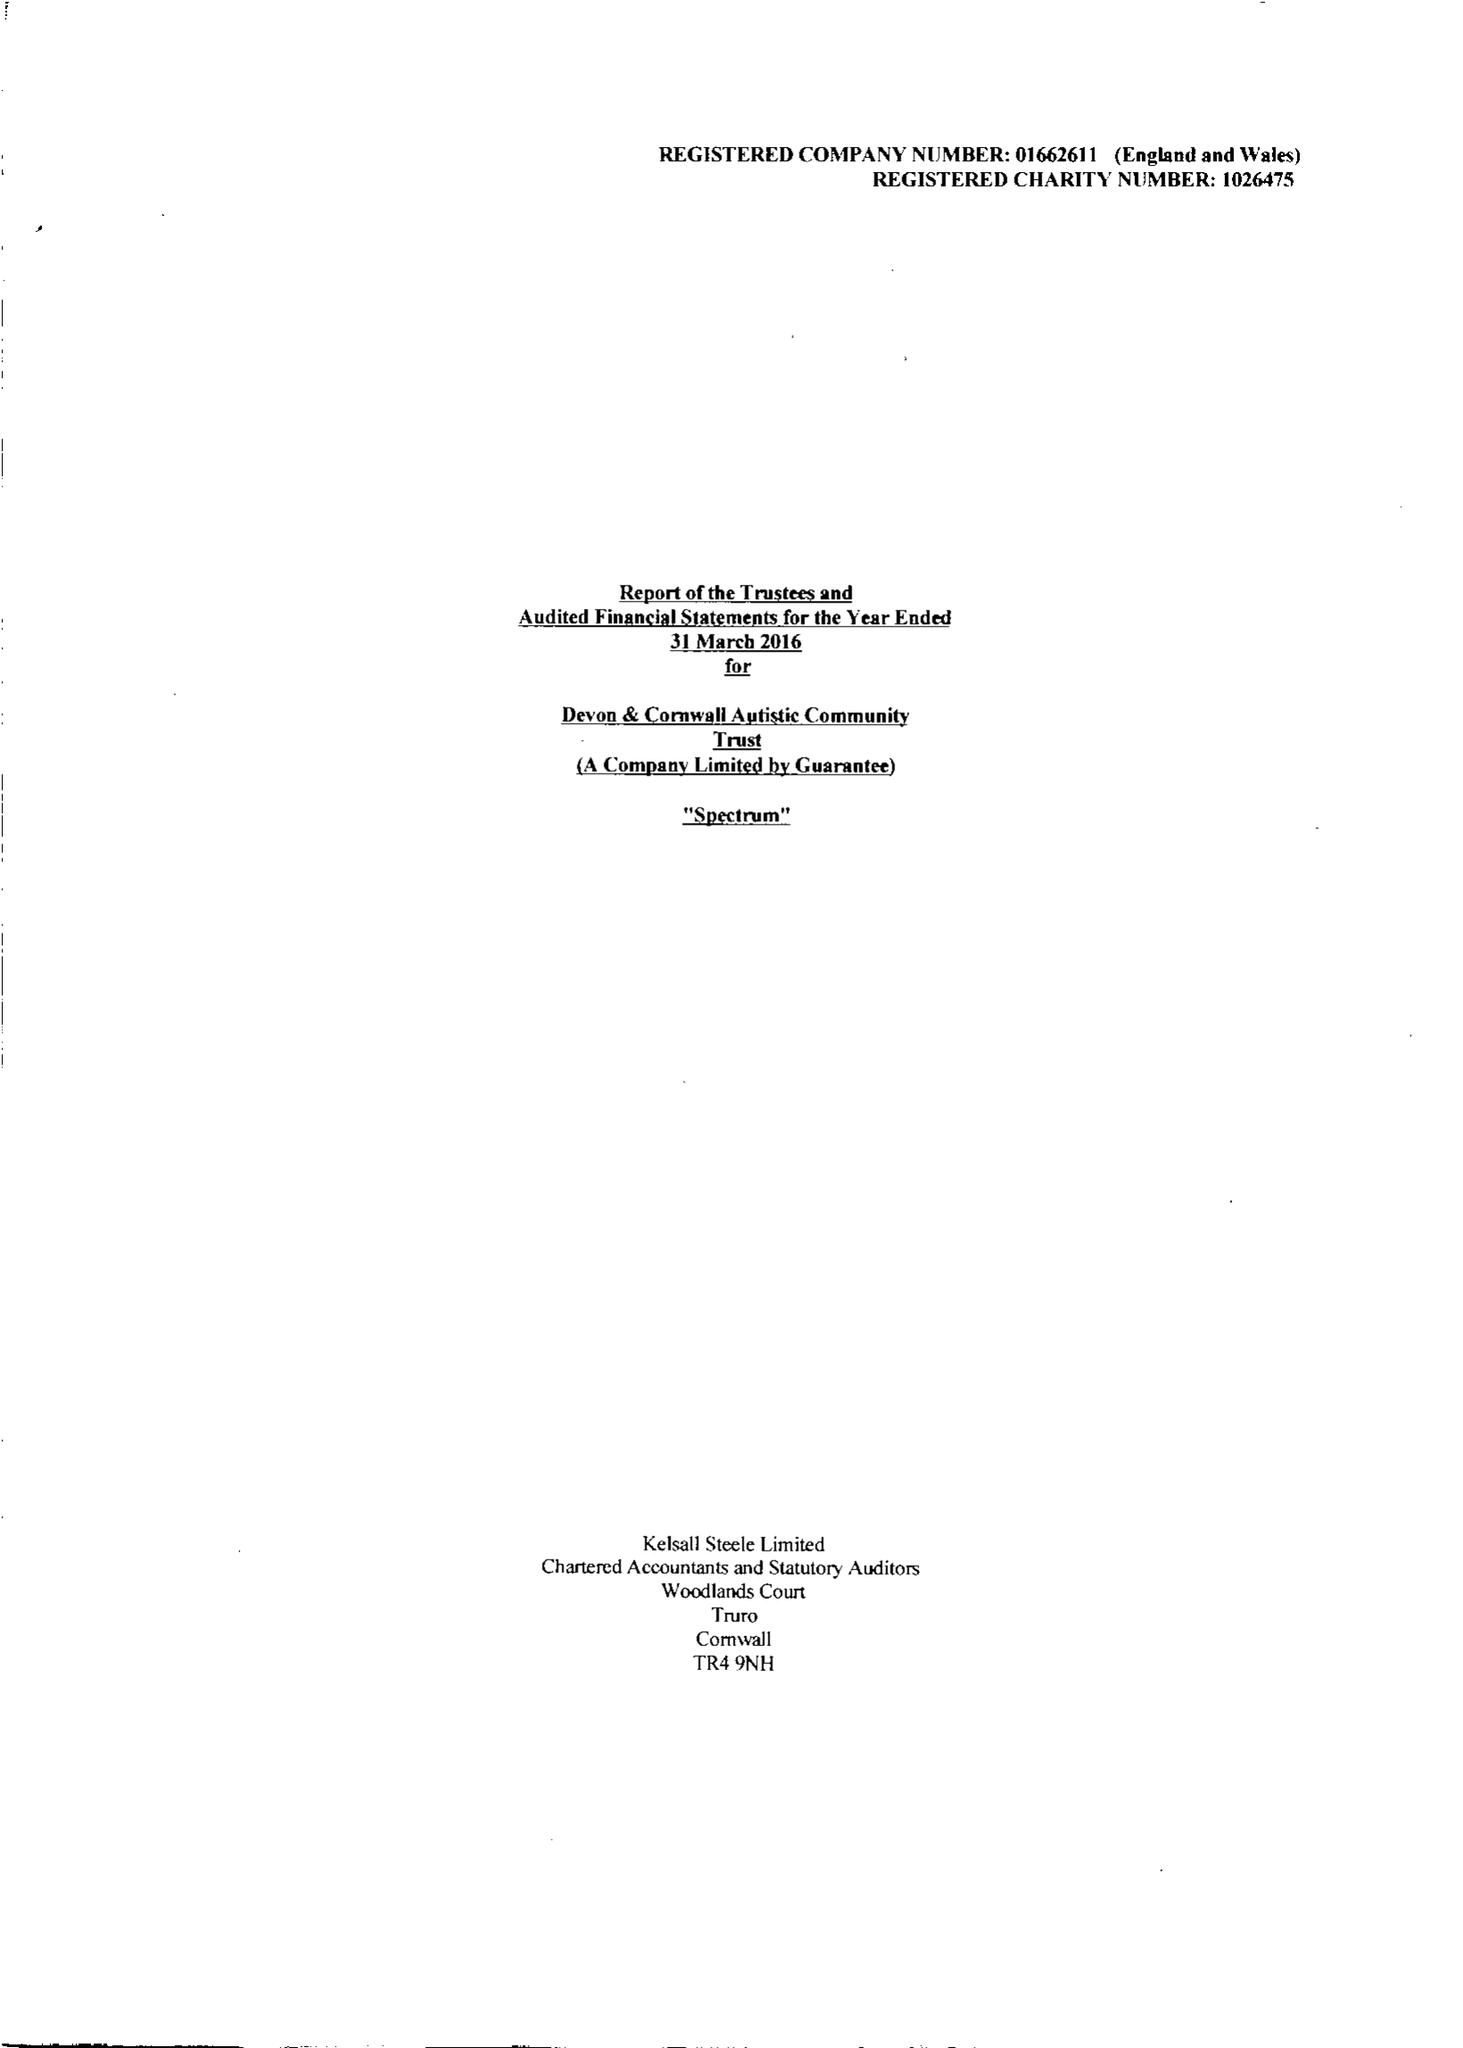What is the value for the income_annually_in_british_pounds?
Answer the question using a single word or phrase. 10888051.00 